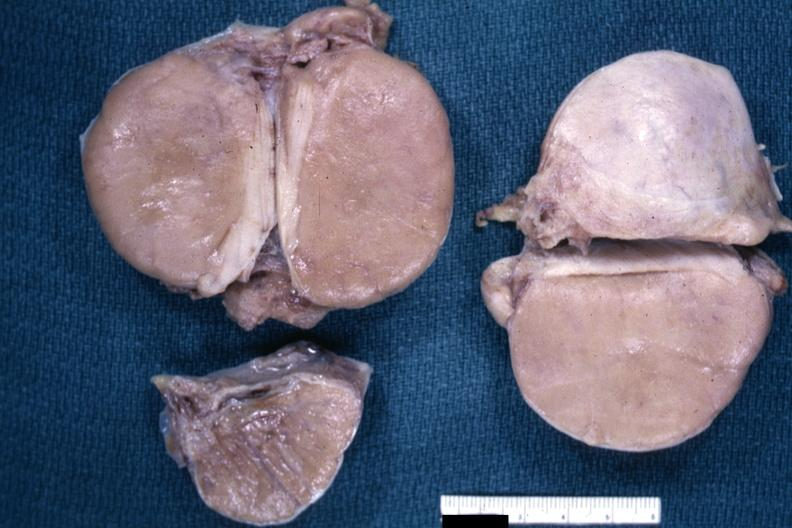s testicle present?
Answer the question using a single word or phrase. Yes 